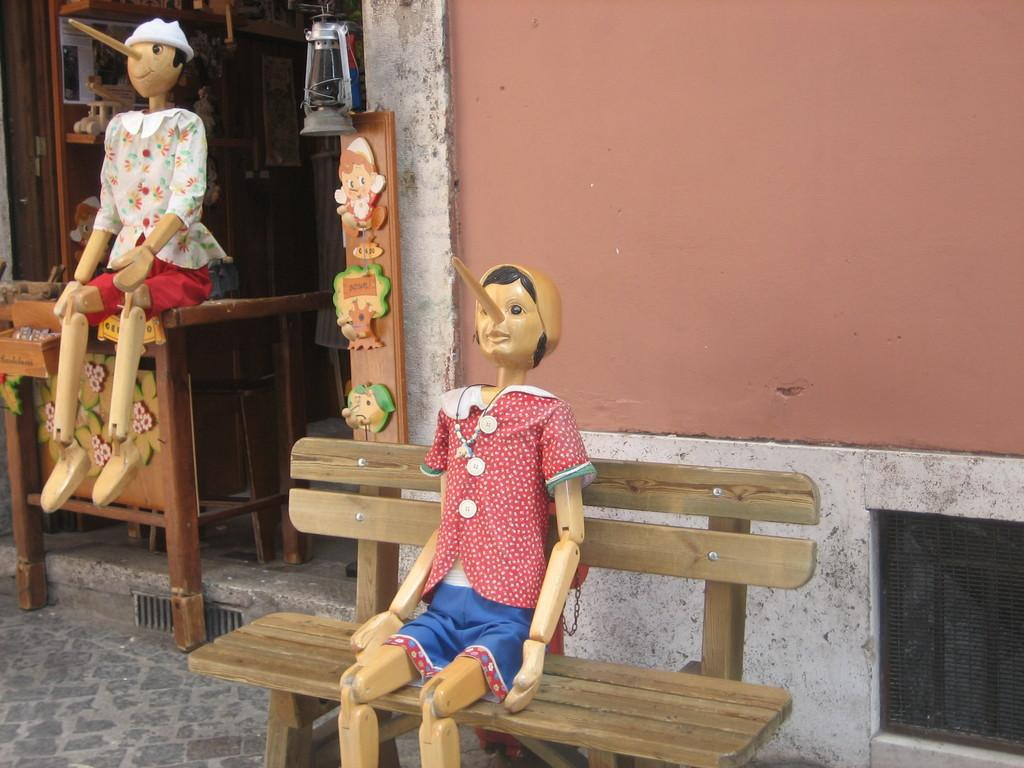What is the girl in the image doing? The girl is sitting on a bench in the image. What object can be seen in the image that provides light? There is a lamp in the image. What is the unusual position of a person in the image? There is a person sitting on a table in the image. What type of furniture can be seen in the background of the image? There are cupboards in the background of the image. What is visible in the background of the image that separates the different areas? There is a wall visible in the background of the image. What statement does the girl make about downtown in the image? There is no statement made by the girl about downtown in the image, as the provided facts do not mention anything about downtown. What is the condition of the girl's mouth in the image? The condition of the girl's mouth is not mentioned in the provided facts, so it cannot be determined from the image. 